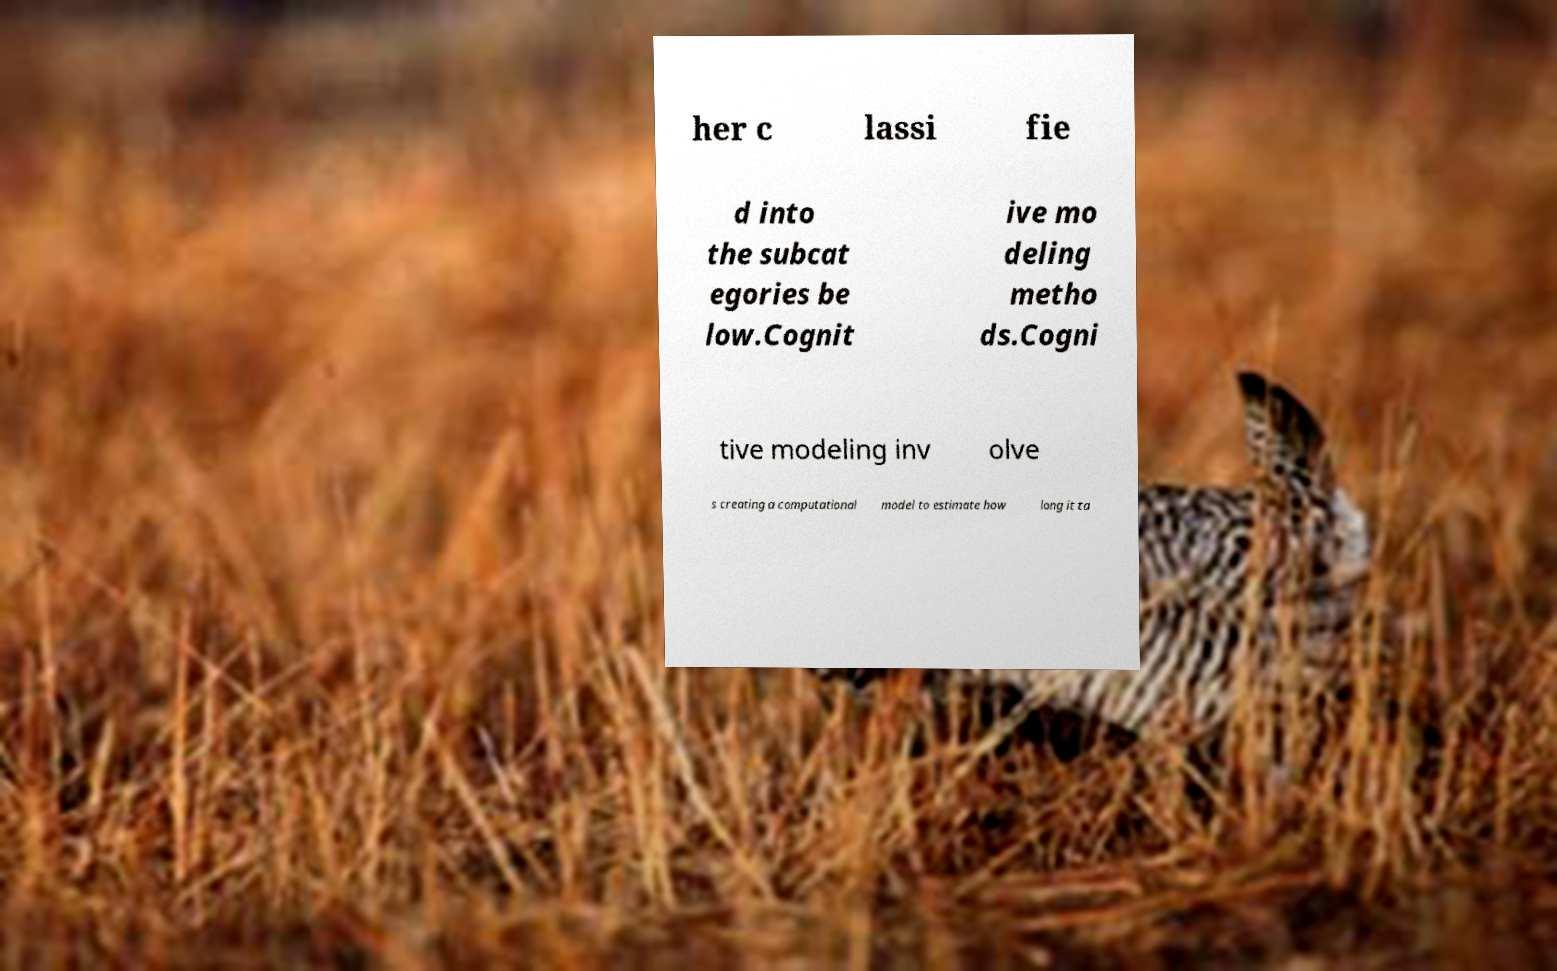For documentation purposes, I need the text within this image transcribed. Could you provide that? her c lassi fie d into the subcat egories be low.Cognit ive mo deling metho ds.Cogni tive modeling inv olve s creating a computational model to estimate how long it ta 